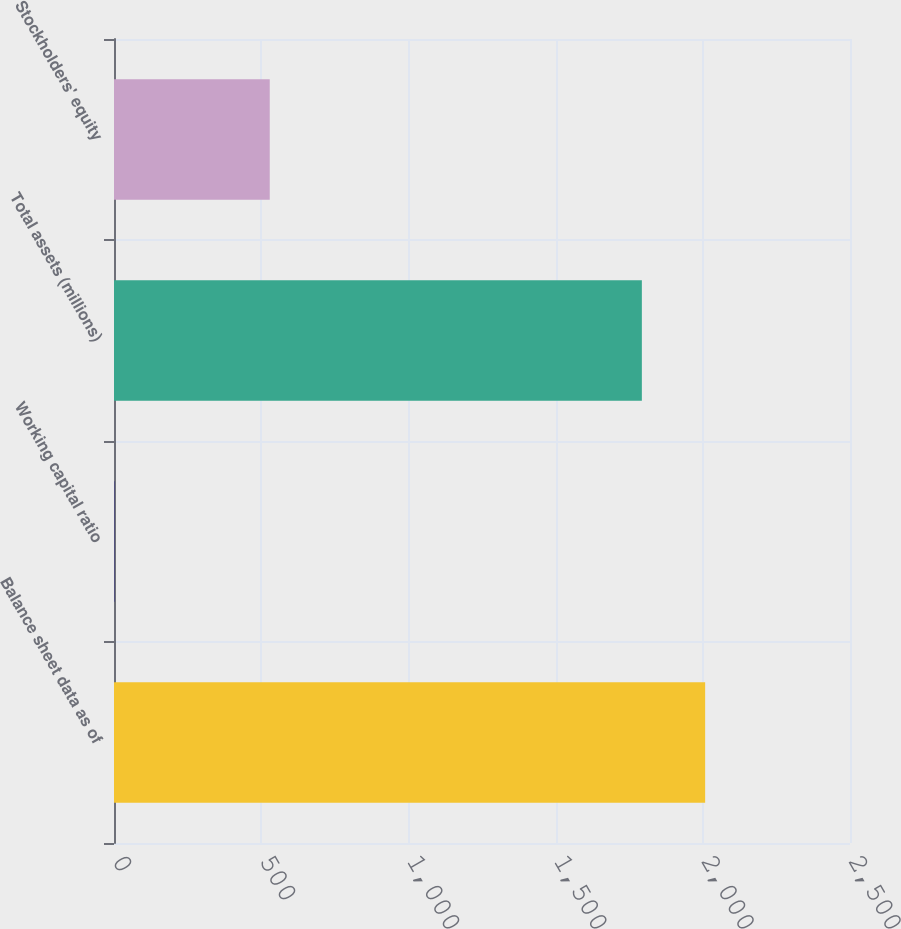Convert chart to OTSL. <chart><loc_0><loc_0><loc_500><loc_500><bar_chart><fcel>Balance sheet data as of<fcel>Working capital ratio<fcel>Total assets (millions)<fcel>Stockholders' equity<nl><fcel>2008<fcel>0.97<fcel>1793<fcel>529<nl></chart> 